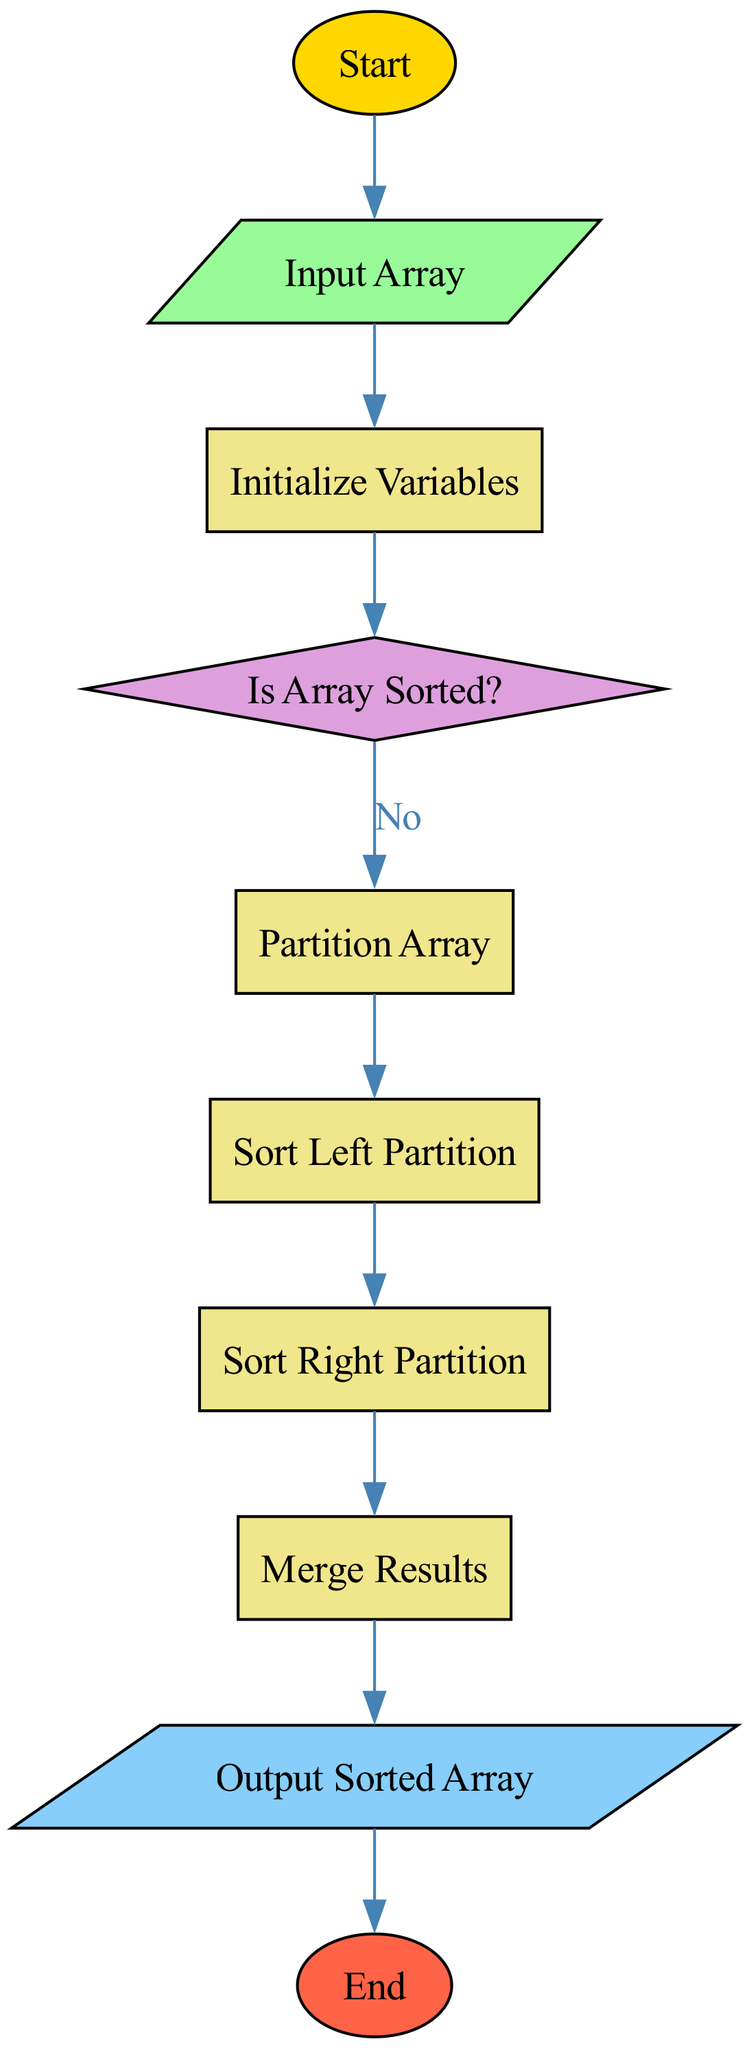What is the first step in the flowchart? The flowchart starts with the "Start" node, which indicates the beginning of the process.
Answer: Start How many process nodes are in the flowchart? By counting the nodes labeled as 'process', we find a total of four process nodes in the diagram: "Initialize Variables", "Partition Array", "Sort Left Partition", and "Sort Right Partition", making it four in total.
Answer: Four What condition is checked after initializing variables? The condition checked is whether the array is sorted, which is labeled as "Is Array Sorted?".
Answer: Is Array Sorted? What happens if the array is sorted? If the array is sorted, the flowchart leads to the "End" node, indicating that no further processing is needed.
Answer: End Which process follows "Partition Array"? The process that follows "Partition Array" is "Sort Left Partition". This is the next step in the flow of the sorting algorithm after partitioning the array.
Answer: Sort Left Partition How does the flowchart transition from the decision node? From the decision node "Is Array Sorted?", the flowchart transitions to "partitionArray" if the answer is "No". If the answer is "Yes", it transitions directly to "end". This explains the two conditional paths taken from that decision.
Answer: Yes and No How many edges are there in total in the flowchart? Counting all the directed edges that connect nodes, there are a total of eight edges in this flowchart, representing the transitions between different nodes.
Answer: Eight What must occur before merging results? Before merging results, the algorithm must complete sorting the left and right partitions, indicated by the nodes "Sort Left Partition" and "Sort Right Partition". Both sorting processes must be completed to proceed to merging.
Answer: Sort Left and Right Partitions What is the output of the flowchart? The final output produced by the flowchart is the "Output Sorted Array", representing the sorted result after processing the input array.
Answer: Output Sorted Array 